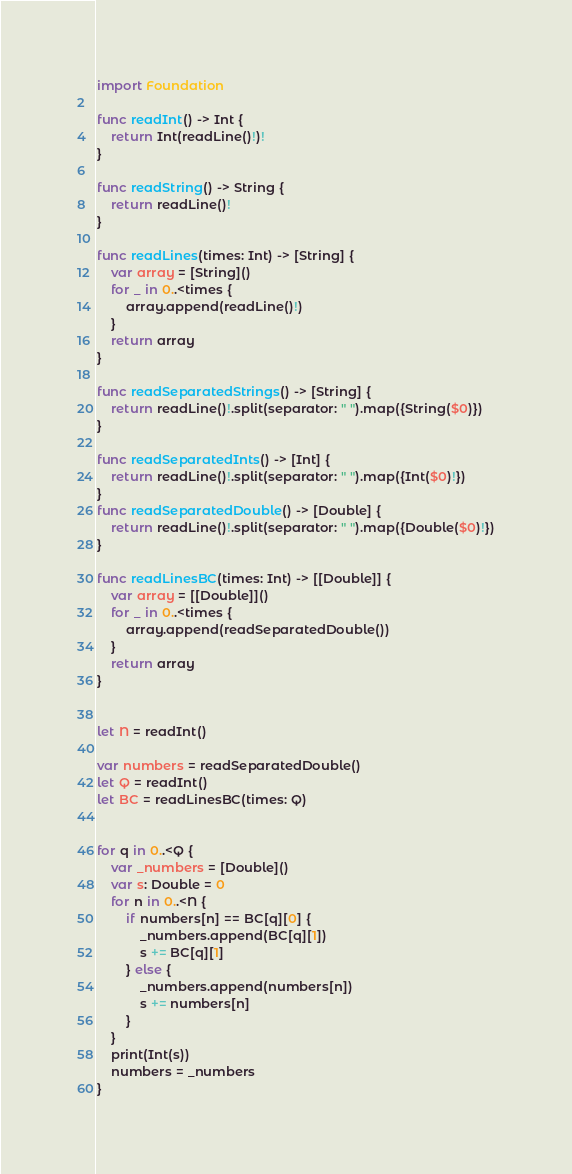Convert code to text. <code><loc_0><loc_0><loc_500><loc_500><_Swift_>import Foundation

func readInt() -> Int {
    return Int(readLine()!)!
}

func readString() -> String {
    return readLine()!
}

func readLines(times: Int) -> [String] {
    var array = [String]()
    for _ in 0..<times {
        array.append(readLine()!)
    }
    return array
}

func readSeparatedStrings() -> [String] {
    return readLine()!.split(separator: " ").map({String($0)})
}

func readSeparatedInts() -> [Int] {
    return readLine()!.split(separator: " ").map({Int($0)!})
}
func readSeparatedDouble() -> [Double] {
    return readLine()!.split(separator: " ").map({Double($0)!})
}

func readLinesBC(times: Int) -> [[Double]] {
    var array = [[Double]]()
    for _ in 0..<times {
        array.append(readSeparatedDouble())
    }
    return array
}


let N = readInt()

var numbers = readSeparatedDouble()
let Q = readInt()
let BC = readLinesBC(times: Q)


for q in 0..<Q {
    var _numbers = [Double]()
    var s: Double = 0
    for n in 0..<N {
        if numbers[n] == BC[q][0] {
            _numbers.append(BC[q][1])
            s += BC[q][1]
        } else {
            _numbers.append(numbers[n])
            s += numbers[n]
        }
    }
    print(Int(s))
    numbers = _numbers
}

</code> 